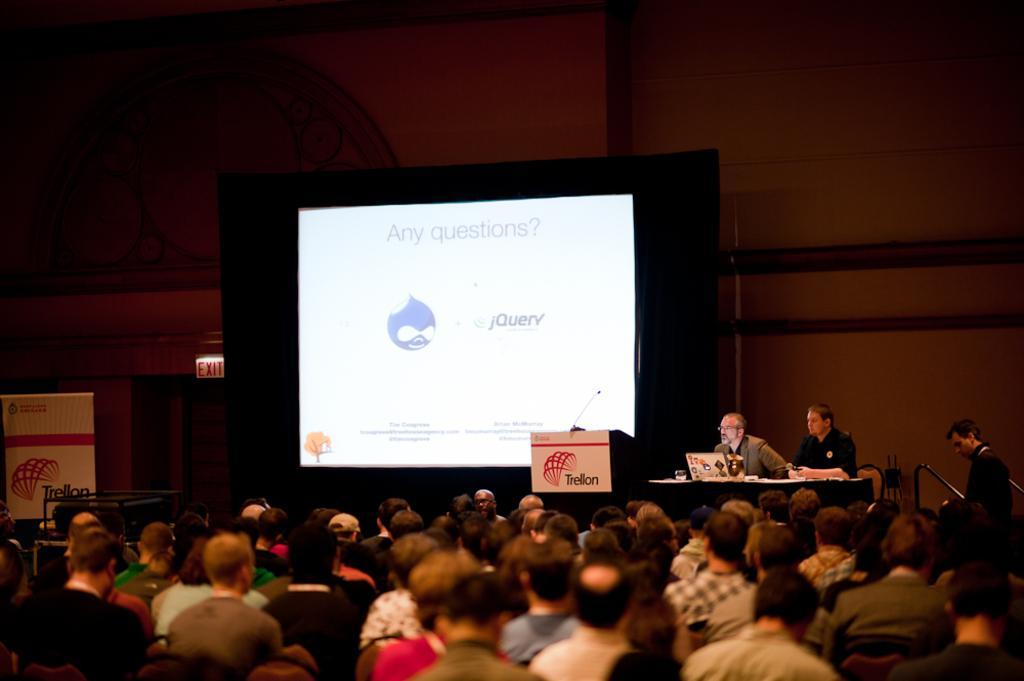Please provide a concise description of this image. In this image I can see the group of people with the different color dresses. In- front of these people I can see two people sitting and one person standing. I can see the table in-front of two people and there are many objects in it. To the side I can see the screen and board. In the background I can see the wall. 